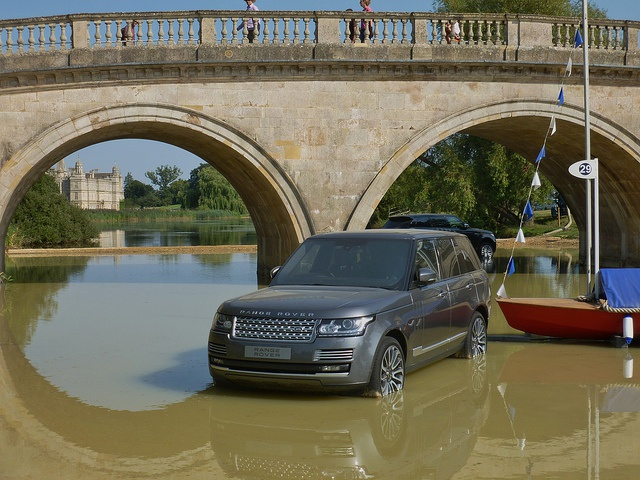Describe the objects in this image and their specific colors. I can see car in gray, black, darkblue, and darkgreen tones, boat in gray, maroon, black, lightgray, and blue tones, car in gray, black, blue, and navy tones, people in gray, black, and darkgray tones, and people in gray, black, maroon, and brown tones in this image. 